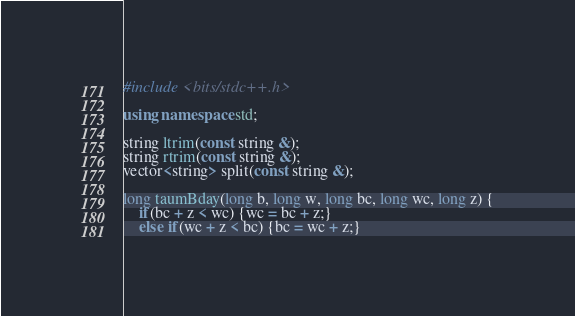Convert code to text. <code><loc_0><loc_0><loc_500><loc_500><_C++_>#include <bits/stdc++.h>

using namespace std;

string ltrim(const string &);
string rtrim(const string &);
vector<string> split(const string &);

long taumBday(long b, long w, long bc, long wc, long z) {
    if(bc + z < wc) {wc = bc + z;} 
    else if(wc + z < bc) {bc = wc + z;} </code> 